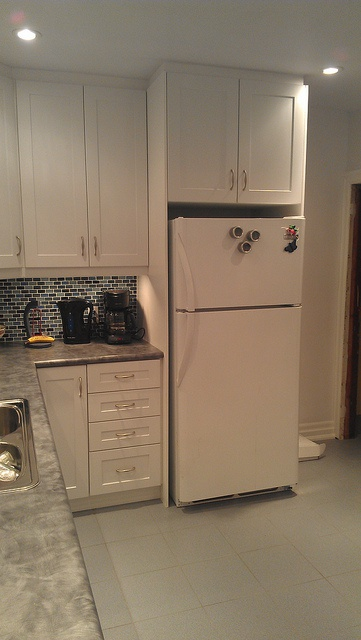Describe the objects in this image and their specific colors. I can see refrigerator in gray and black tones, sink in gray and black tones, and banana in gray, orange, maroon, and olive tones in this image. 